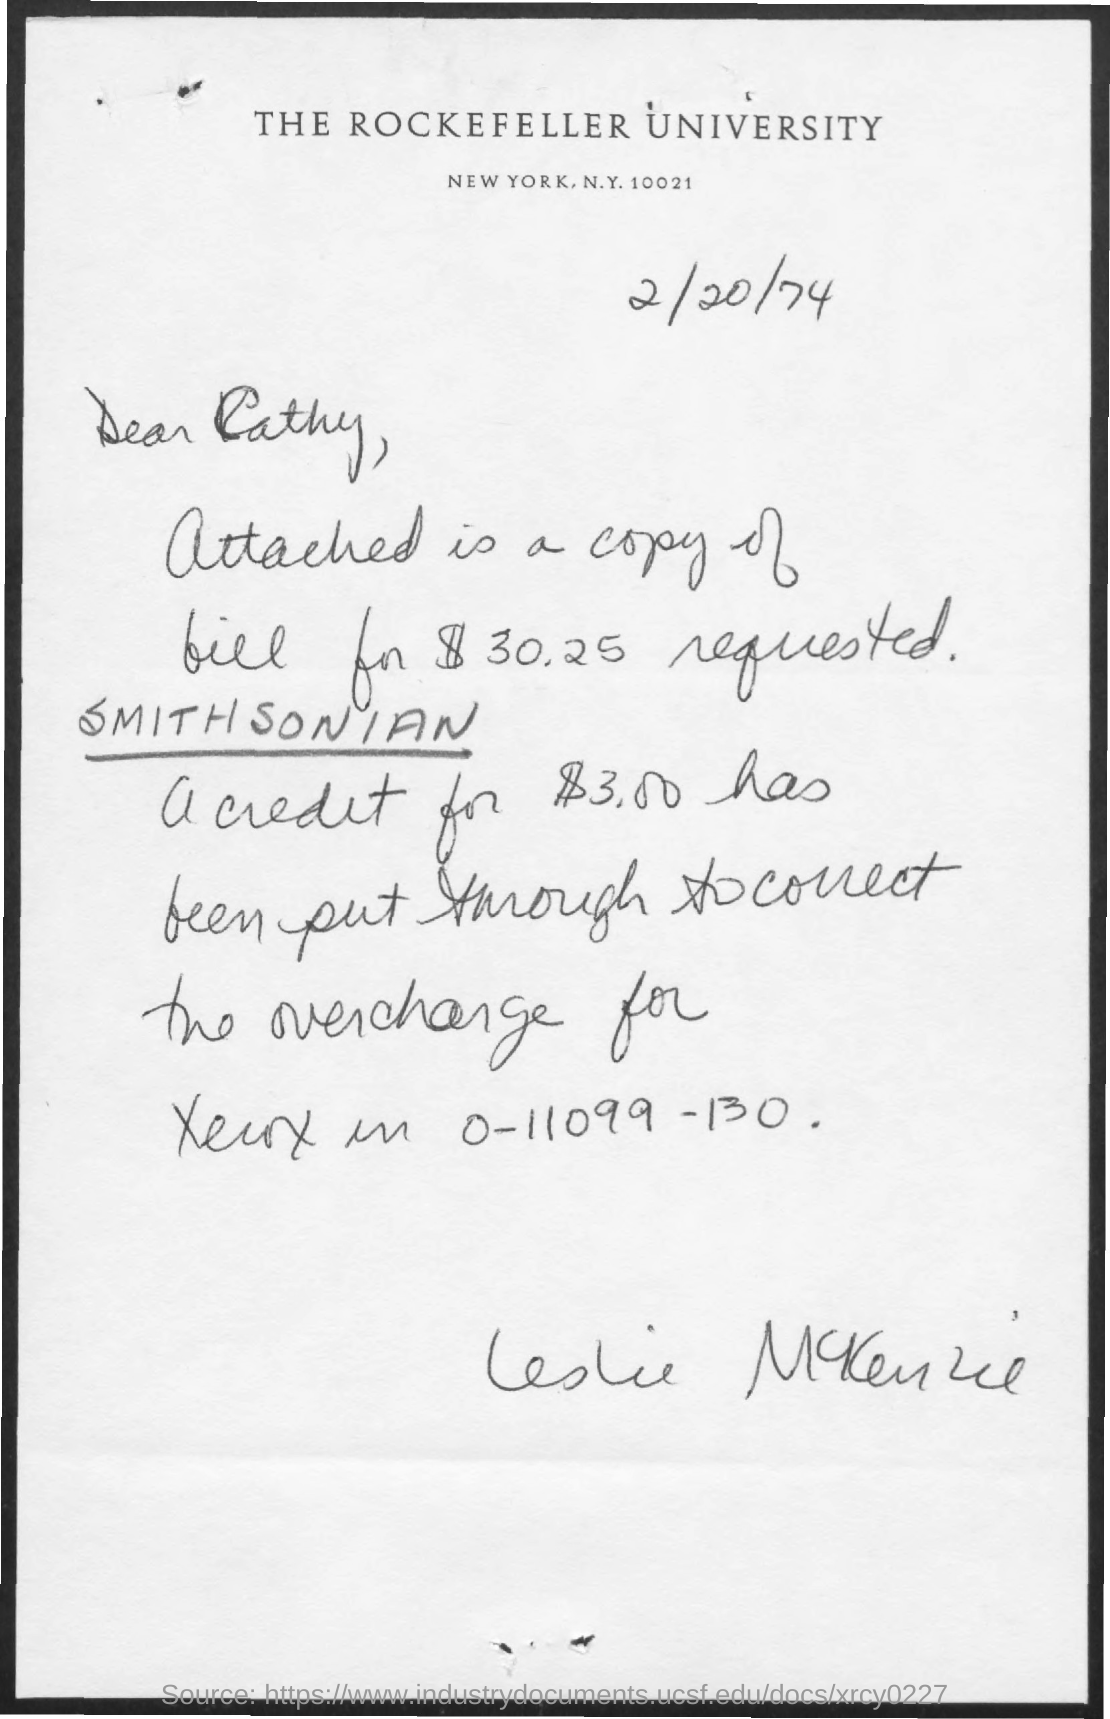Identify some key points in this picture. The letter is addressed to Cathy. The Rockefeller University is mentioned. The document is dated 2/20/74. 